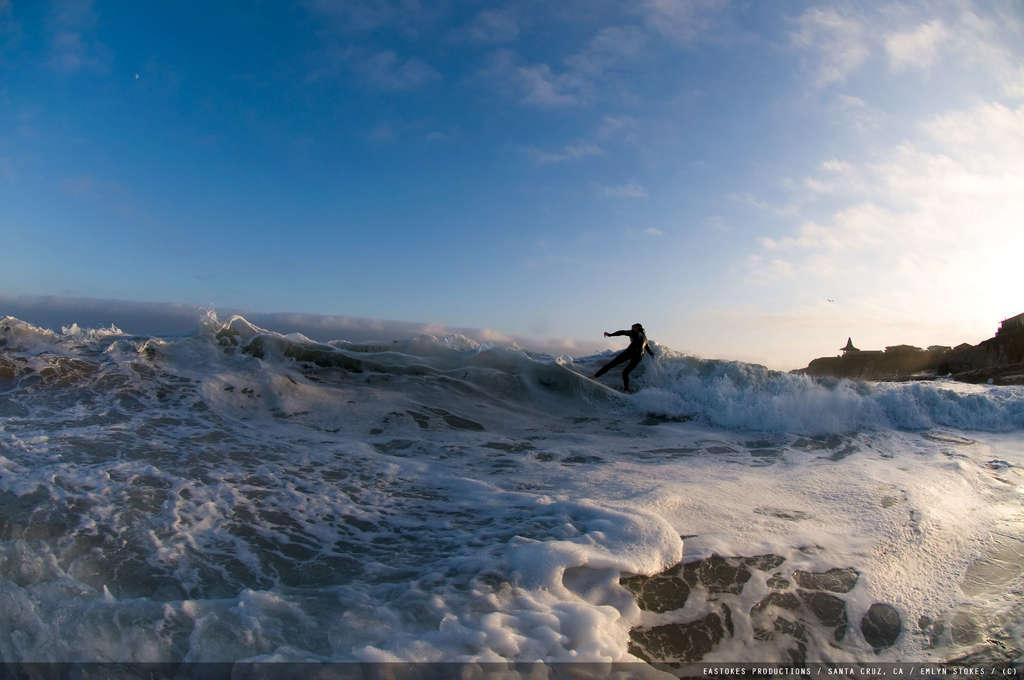What is the person in the image doing? The person is surfing on a surfboard in the image. What is the person surfing on? The person is surfing on the water. What can be seen in the image besides the person and the water? There is a wave and a hill visible in the image. What is visible in the background of the image? The sky is visible in the background of the image, and there are clouds in the sky. What type of fog can be seen in the image? There is no fog present in the image; it features a person surfing on a wave with a clear sky and clouds visible. 